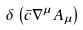<formula> <loc_0><loc_0><loc_500><loc_500>\delta \left ( \bar { c } \nabla ^ { \mu } A _ { \mu } \right )</formula> 